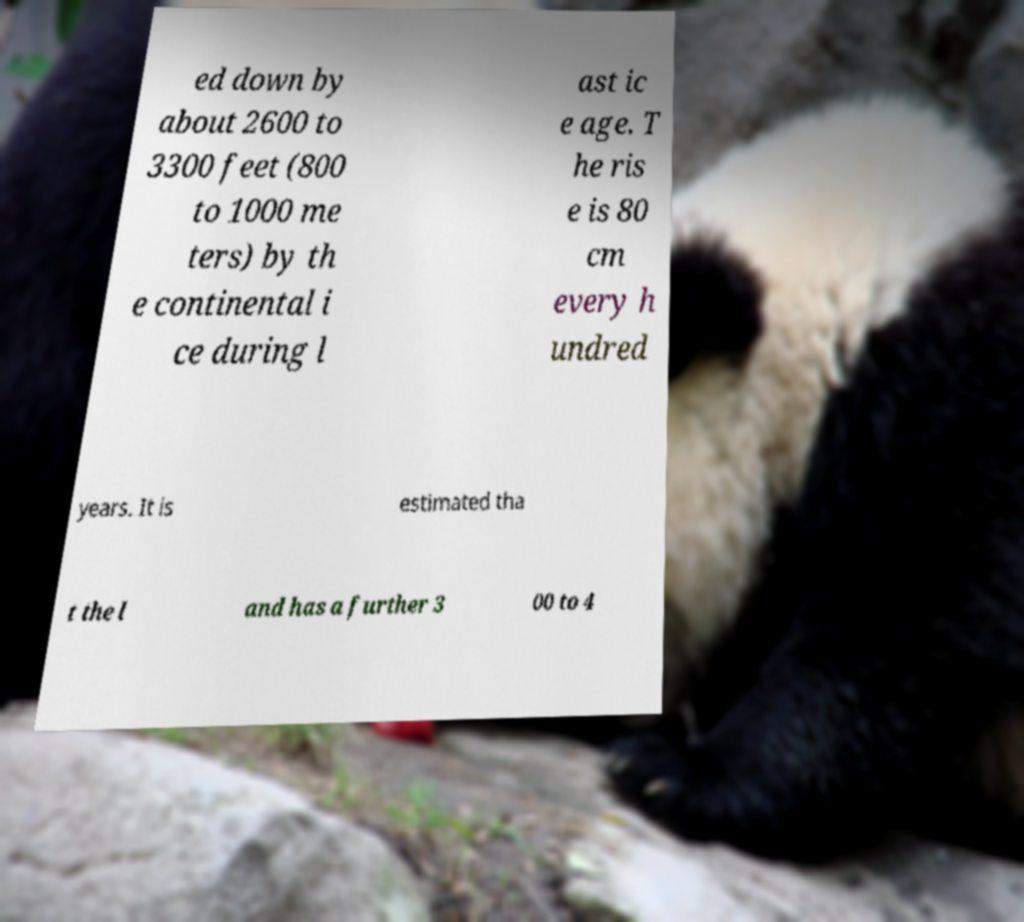There's text embedded in this image that I need extracted. Can you transcribe it verbatim? ed down by about 2600 to 3300 feet (800 to 1000 me ters) by th e continental i ce during l ast ic e age. T he ris e is 80 cm every h undred years. It is estimated tha t the l and has a further 3 00 to 4 